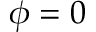Convert formula to latex. <formula><loc_0><loc_0><loc_500><loc_500>\phi = 0</formula> 